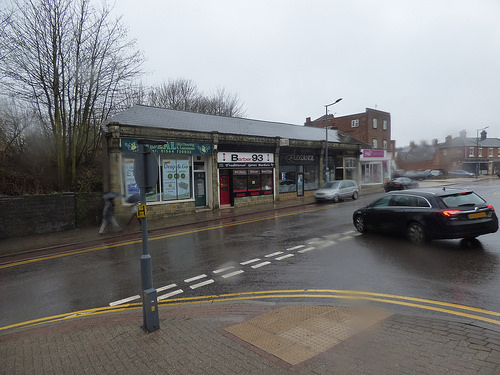<image>
Can you confirm if the car is next to the building? No. The car is not positioned next to the building. They are located in different areas of the scene. 